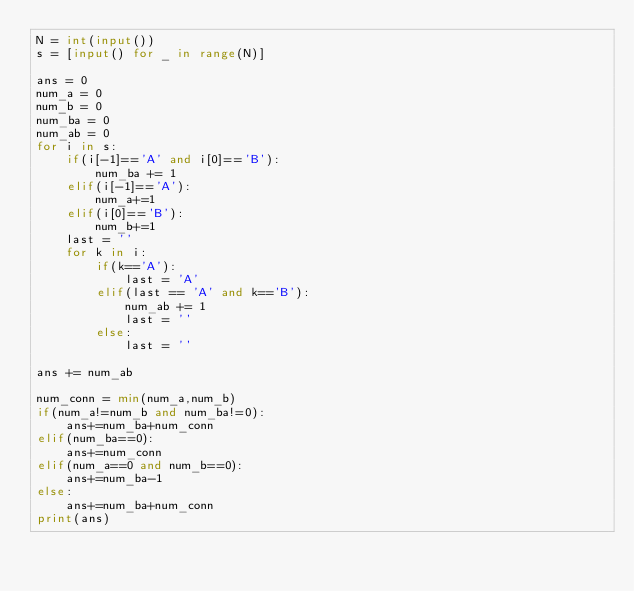Convert code to text. <code><loc_0><loc_0><loc_500><loc_500><_Python_>N = int(input())
s = [input() for _ in range(N)]

ans = 0
num_a = 0
num_b = 0
num_ba = 0
num_ab = 0
for i in s:
    if(i[-1]=='A' and i[0]=='B'):
        num_ba += 1
    elif(i[-1]=='A'):
        num_a+=1
    elif(i[0]=='B'):
        num_b+=1
    last = ''
    for k in i:
        if(k=='A'):
            last = 'A'
        elif(last == 'A' and k=='B'):
            num_ab += 1
            last = ''
        else:
            last = ''

ans += num_ab

num_conn = min(num_a,num_b)
if(num_a!=num_b and num_ba!=0):
    ans+=num_ba+num_conn
elif(num_ba==0):
    ans+=num_conn
elif(num_a==0 and num_b==0):
    ans+=num_ba-1
else:
    ans+=num_ba+num_conn
print(ans)
</code> 